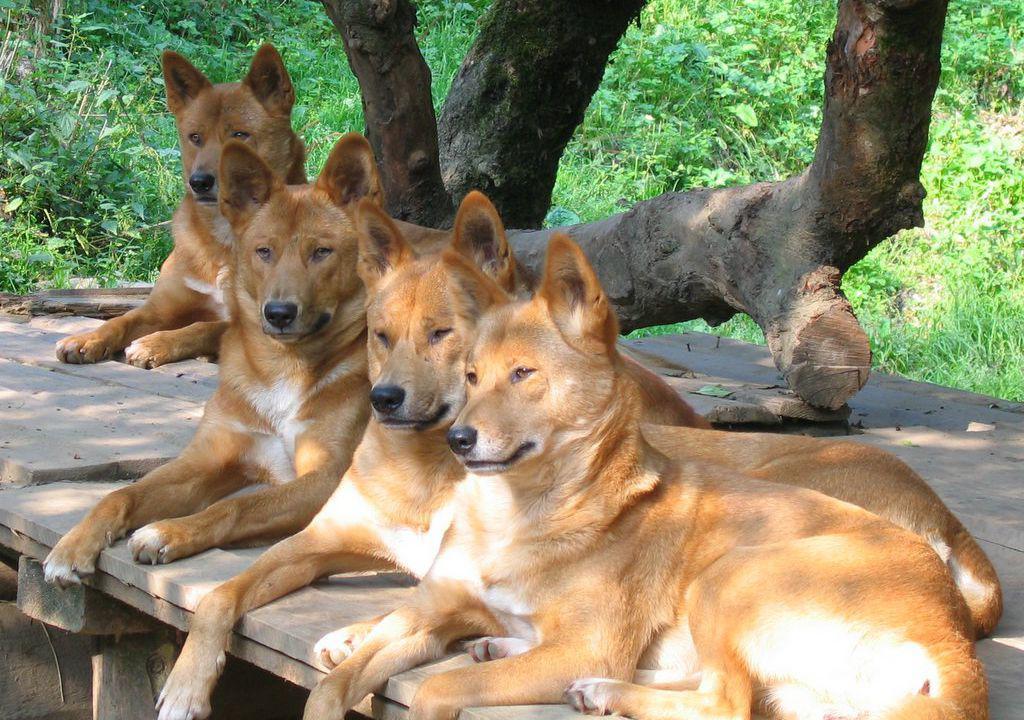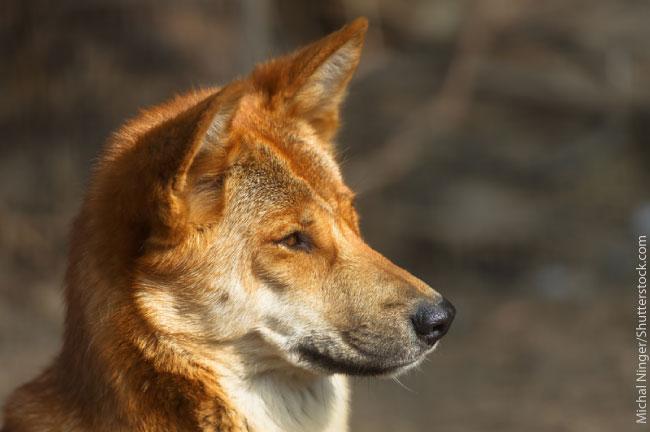The first image is the image on the left, the second image is the image on the right. Examine the images to the left and right. Is the description "There is a single tan and white canine facing left standing on the tan and green grass." accurate? Answer yes or no. No. The first image is the image on the left, the second image is the image on the right. Given the left and right images, does the statement "In the left image, a lone dog stands up, and is looking right at the camera." hold true? Answer yes or no. No. 